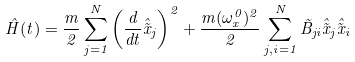<formula> <loc_0><loc_0><loc_500><loc_500>\hat { H } ( t ) = \frac { m } { 2 } \sum _ { j = 1 } ^ { N } \left ( \frac { d } { d t } \hat { \tilde { x } } _ { j } \right ) ^ { 2 } + \frac { m ( \omega _ { x } ^ { 0 } ) ^ { 2 } } { 2 } \sum _ { j , i = 1 } ^ { N } \tilde { B } _ { j i } \hat { \tilde { x } } _ { j } \hat { \tilde { x } } _ { i }</formula> 